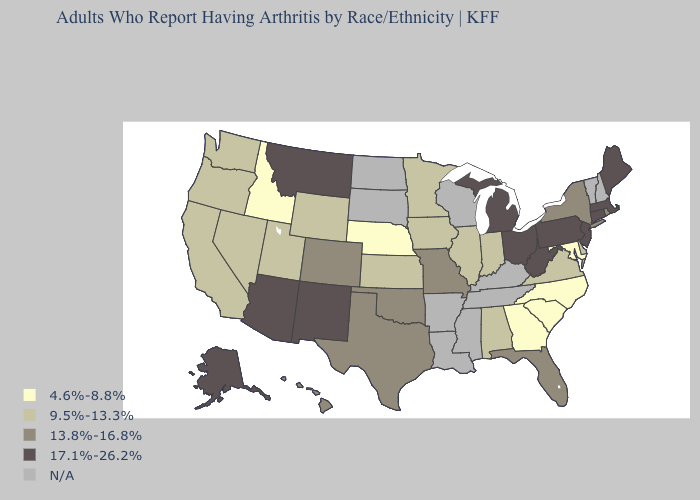What is the lowest value in the South?
Give a very brief answer. 4.6%-8.8%. Does the first symbol in the legend represent the smallest category?
Give a very brief answer. Yes. What is the value of North Carolina?
Keep it brief. 4.6%-8.8%. Name the states that have a value in the range 13.8%-16.8%?
Answer briefly. Colorado, Florida, Hawaii, Missouri, New York, Oklahoma, Rhode Island, Texas. Name the states that have a value in the range N/A?
Quick response, please. Arkansas, Kentucky, Louisiana, Mississippi, New Hampshire, North Dakota, South Dakota, Tennessee, Vermont, Wisconsin. Name the states that have a value in the range N/A?
Quick response, please. Arkansas, Kentucky, Louisiana, Mississippi, New Hampshire, North Dakota, South Dakota, Tennessee, Vermont, Wisconsin. What is the value of Florida?
Be succinct. 13.8%-16.8%. Does Arizona have the highest value in the USA?
Write a very short answer. Yes. What is the value of New Hampshire?
Short answer required. N/A. Which states have the lowest value in the South?
Write a very short answer. Georgia, Maryland, North Carolina, South Carolina. Does Michigan have the highest value in the MidWest?
Short answer required. Yes. What is the value of Hawaii?
Keep it brief. 13.8%-16.8%. What is the value of West Virginia?
Answer briefly. 17.1%-26.2%. 